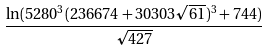<formula> <loc_0><loc_0><loc_500><loc_500>\frac { \ln ( 5 2 8 0 ^ { 3 } ( 2 3 6 6 7 4 + 3 0 3 0 3 { \sqrt { 6 1 } } ) ^ { 3 } + 7 4 4 ) } { \sqrt { 4 2 7 } }</formula> 